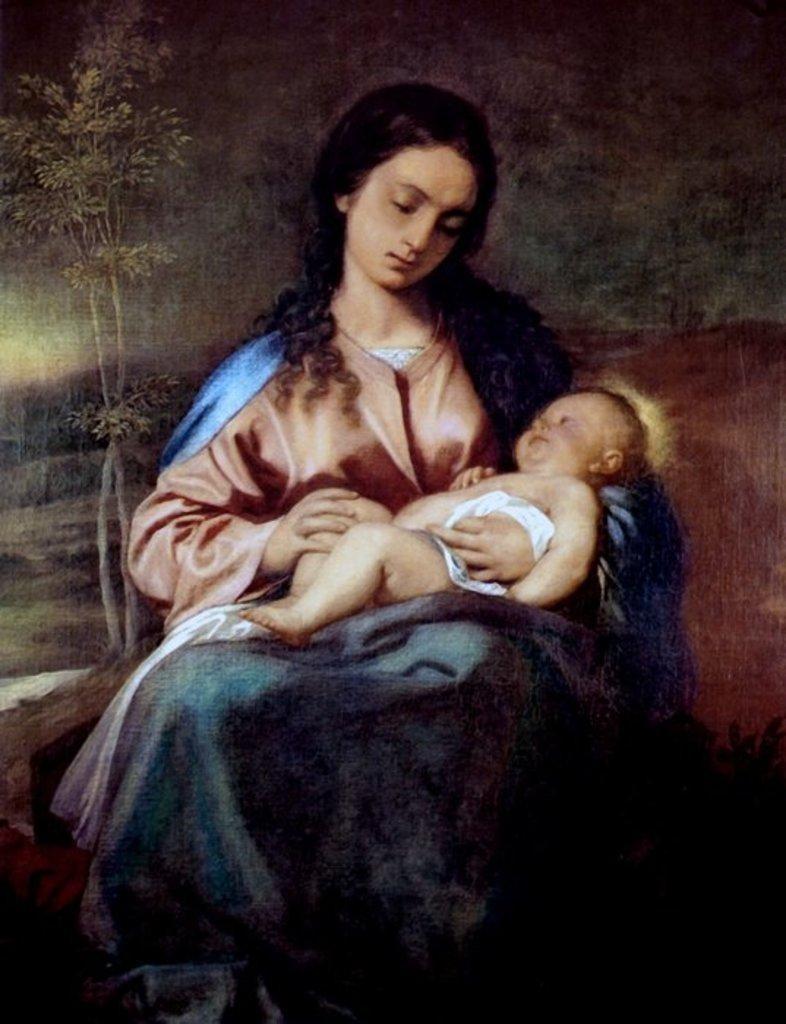Describe this image in one or two sentences. In this picture there is a painting poster of a woman wearing pink color top holding a small baby in the hand. Behind there is a small plant. 